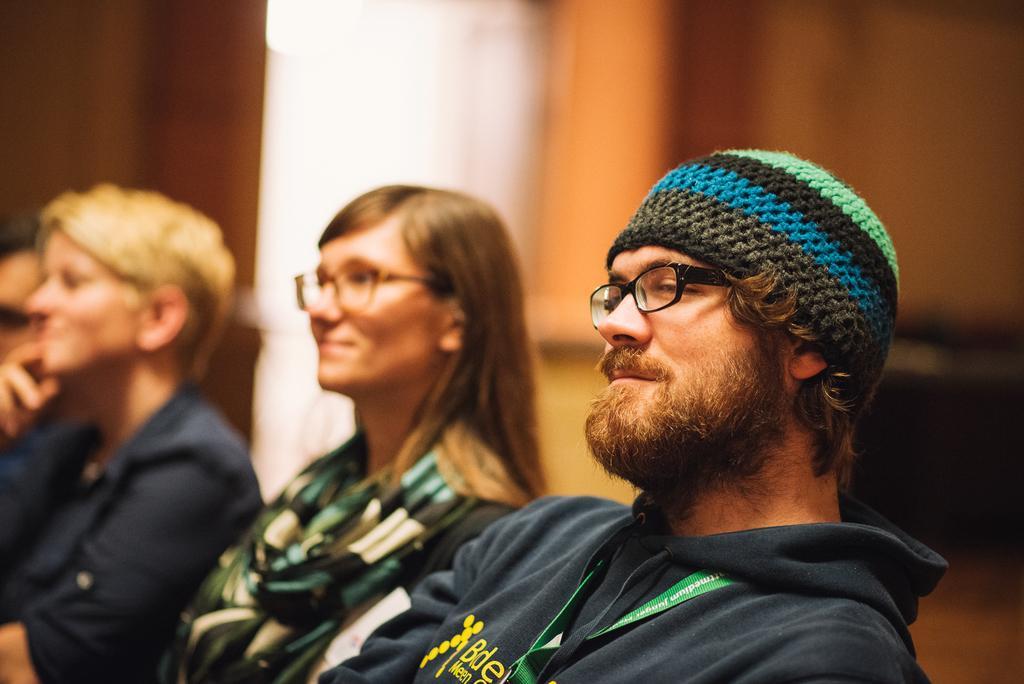Describe this image in one or two sentences. In this picture we can see a man and a woman wearing spectacles on their eyes. There are two people visible on the left side. It seems like a pillar in the background. Background is blurry. 